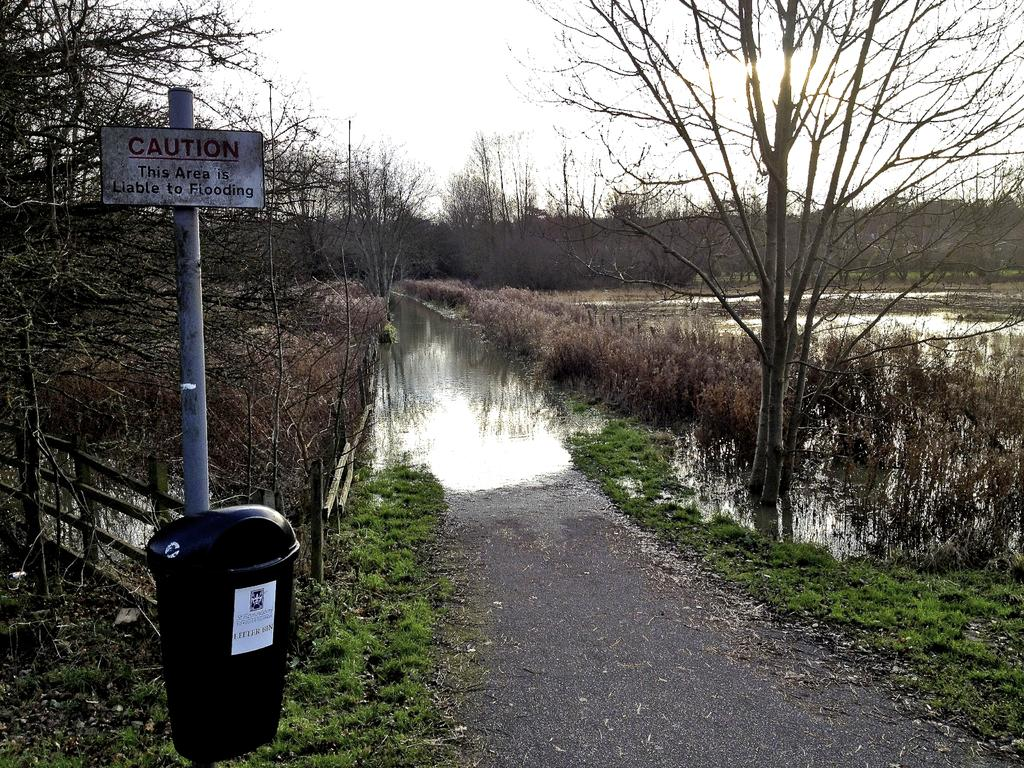<image>
Share a concise interpretation of the image provided. A wooded and flooded area has a CAUTION This area is Liable to Flooding sign displayed. 